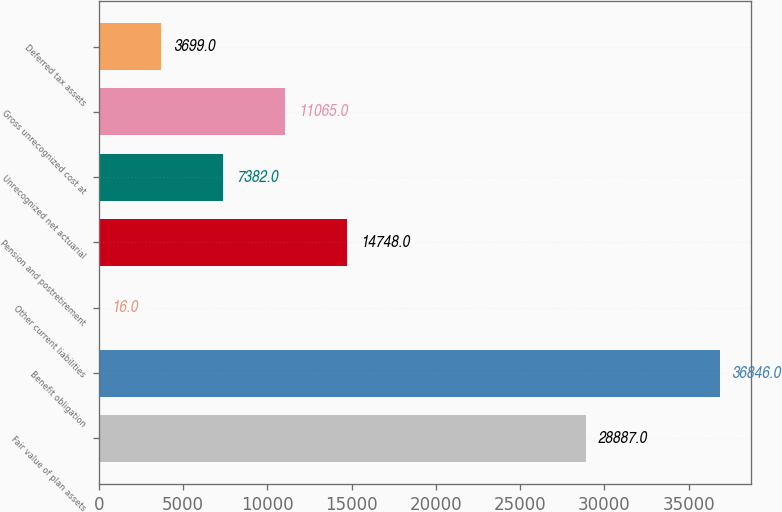Convert chart. <chart><loc_0><loc_0><loc_500><loc_500><bar_chart><fcel>Fair value of plan assets<fcel>Benefit obligation<fcel>Other current liabilities<fcel>Pension and postretirement<fcel>Unrecognized net actuarial<fcel>Gross unrecognized cost at<fcel>Deferred tax assets<nl><fcel>28887<fcel>36846<fcel>16<fcel>14748<fcel>7382<fcel>11065<fcel>3699<nl></chart> 